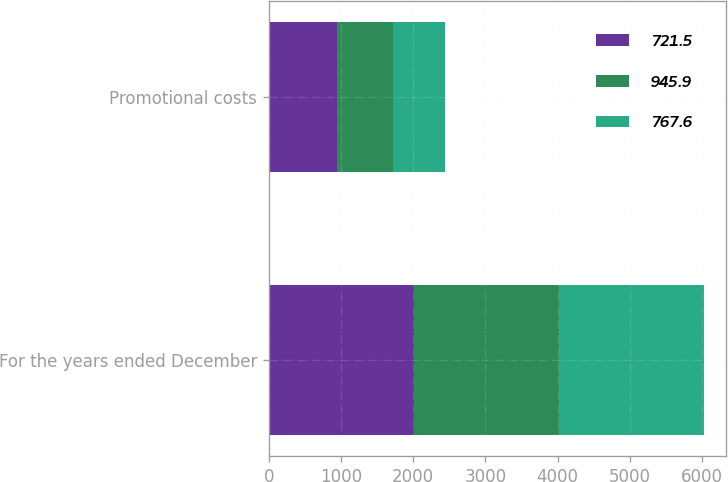<chart> <loc_0><loc_0><loc_500><loc_500><stacked_bar_chart><ecel><fcel>For the years ended December<fcel>Promotional costs<nl><fcel>721.5<fcel>2011<fcel>945.9<nl><fcel>945.9<fcel>2010<fcel>767.6<nl><fcel>767.6<fcel>2009<fcel>721.5<nl></chart> 